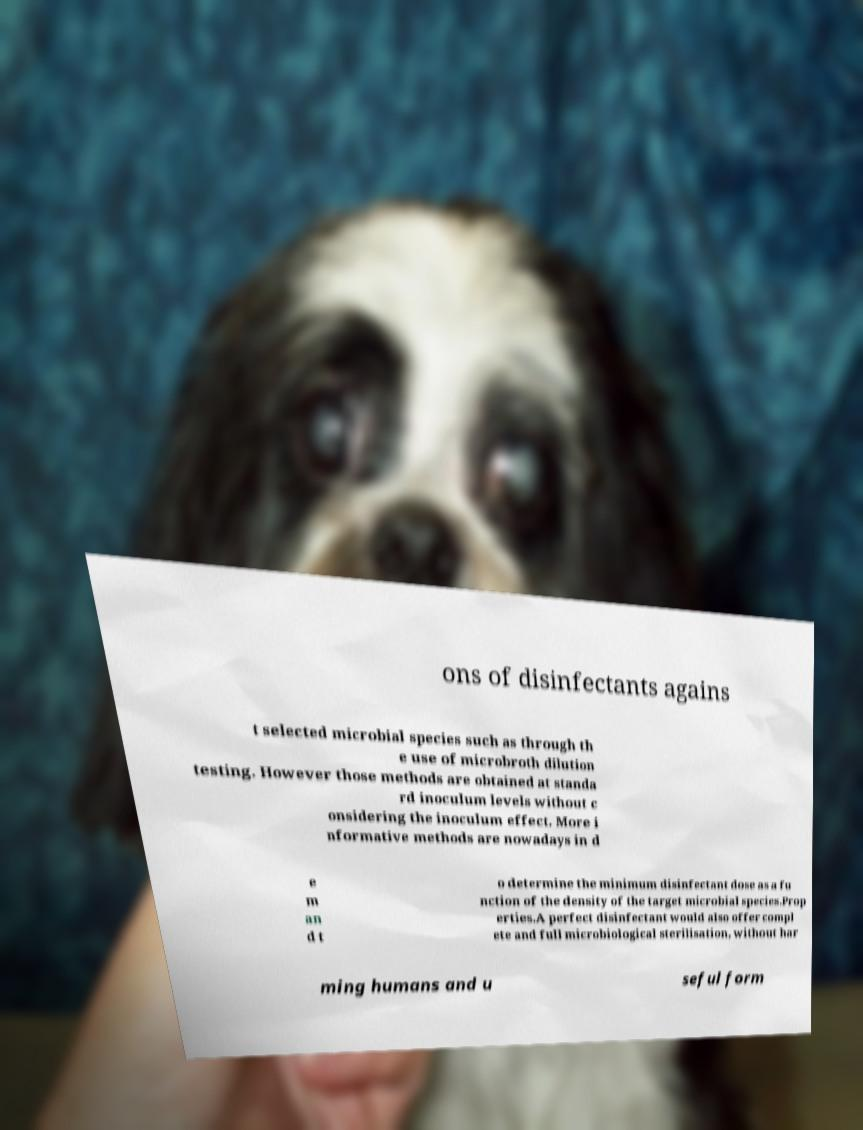Can you accurately transcribe the text from the provided image for me? ons of disinfectants agains t selected microbial species such as through th e use of microbroth dilution testing. However those methods are obtained at standa rd inoculum levels without c onsidering the inoculum effect. More i nformative methods are nowadays in d e m an d t o determine the minimum disinfectant dose as a fu nction of the density of the target microbial species.Prop erties.A perfect disinfectant would also offer compl ete and full microbiological sterilisation, without har ming humans and u seful form 